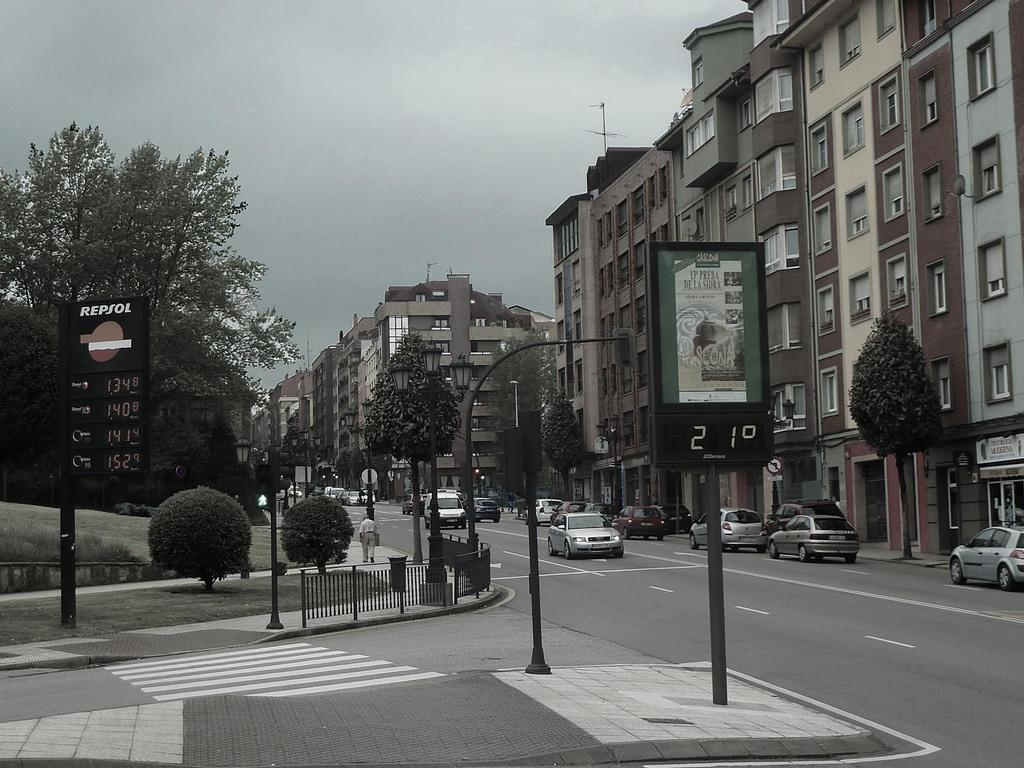<image>
Share a concise interpretation of the image provided. An urban street setting with a sign for Repsol in the corner. 